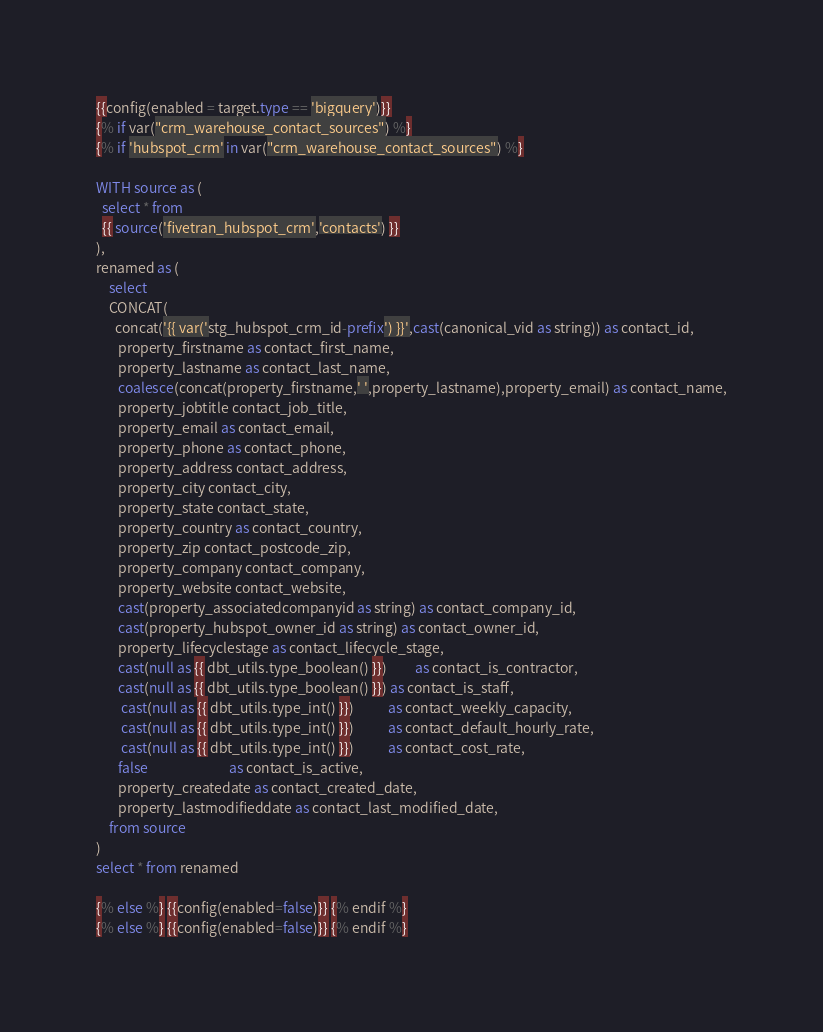Convert code to text. <code><loc_0><loc_0><loc_500><loc_500><_SQL_>{{config(enabled = target.type == 'bigquery')}}
{% if var("crm_warehouse_contact_sources") %}
{% if 'hubspot_crm' in var("crm_warehouse_contact_sources") %}

WITH source as (
  select * from
  {{ source('fivetran_hubspot_crm','contacts') }}
),
renamed as (
    select
    CONCAT(
      concat('{{ var('stg_hubspot_crm_id-prefix') }}',cast(canonical_vid as string)) as contact_id,
       property_firstname as contact_first_name,
       property_lastname as contact_last_name,
       coalesce(concat(property_firstname,' ',property_lastname),property_email) as contact_name,
       property_jobtitle contact_job_title,
       property_email as contact_email,
       property_phone as contact_phone,
       property_address contact_address,
       property_city contact_city,
       property_state contact_state,
       property_country as contact_country,
       property_zip contact_postcode_zip,
       property_company contact_company,
       property_website contact_website,
       cast(property_associatedcompanyid as string) as contact_company_id,
       cast(property_hubspot_owner_id as string) as contact_owner_id,
       property_lifecyclestage as contact_lifecycle_stage,
       cast(null as {{ dbt_utils.type_boolean() }})         as contact_is_contractor,
       cast(null as {{ dbt_utils.type_boolean() }}) as contact_is_staff,
        cast(null as {{ dbt_utils.type_int() }})           as contact_weekly_capacity,
        cast(null as {{ dbt_utils.type_int() }})           as contact_default_hourly_rate,
        cast(null as {{ dbt_utils.type_int() }})           as contact_cost_rate,
       false                          as contact_is_active,
       property_createdate as contact_created_date,
       property_lastmodifieddate as contact_last_modified_date,
    from source
)
select * from renamed

{% else %} {{config(enabled=false)}} {% endif %}
{% else %} {{config(enabled=false)}} {% endif %}
</code> 